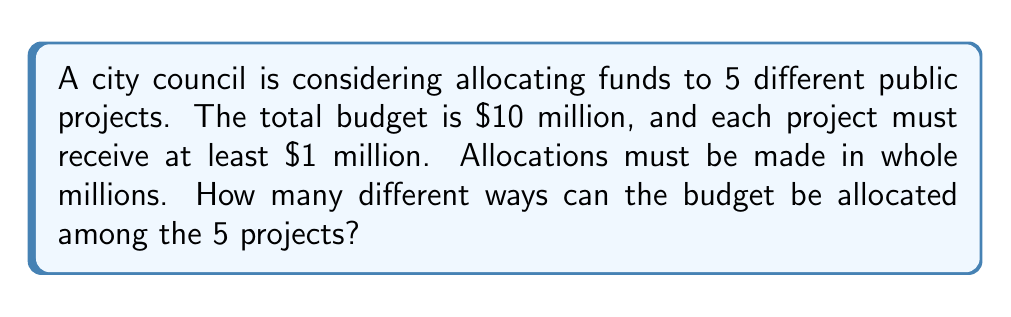Teach me how to tackle this problem. Let's approach this step-by-step:

1) First, we need to allocate the minimum $1 million to each project:
   $5 million total ($1 million × 5 projects)

2) This leaves us with $5 million to distribute among the 5 projects.

3) This problem can be reframed as: In how many ways can we place 5 dividers among 5 objects?

4) This is a classic stars and bars problem. The formula for this is:
   $$\binom{n+k-1}{k-1}$$
   where n is the number of identical objects (in this case, 5 million dollars) and k is the number of groups (5 projects).

5) Plugging in our values:
   $$\binom{5+5-1}{5-1} = \binom{9}{4}$$

6) We can calculate this as:
   $$\binom{9}{4} = \frac{9!}{4!(9-4)!} = \frac{9!}{4!5!}$$

7) Expanding this:
   $$\frac{9 × 8 × 7 × 6 × 5!}{(4 × 3 × 2 × 1) × 5!}$$

8) The 5! cancels out in the numerator and denominator:
   $$\frac{9 × 8 × 7 × 6}{4 × 3 × 2 × 1} = \frac{3024}{24} = 126$$

Therefore, there are 126 different ways to allocate the budget.
Answer: 126 